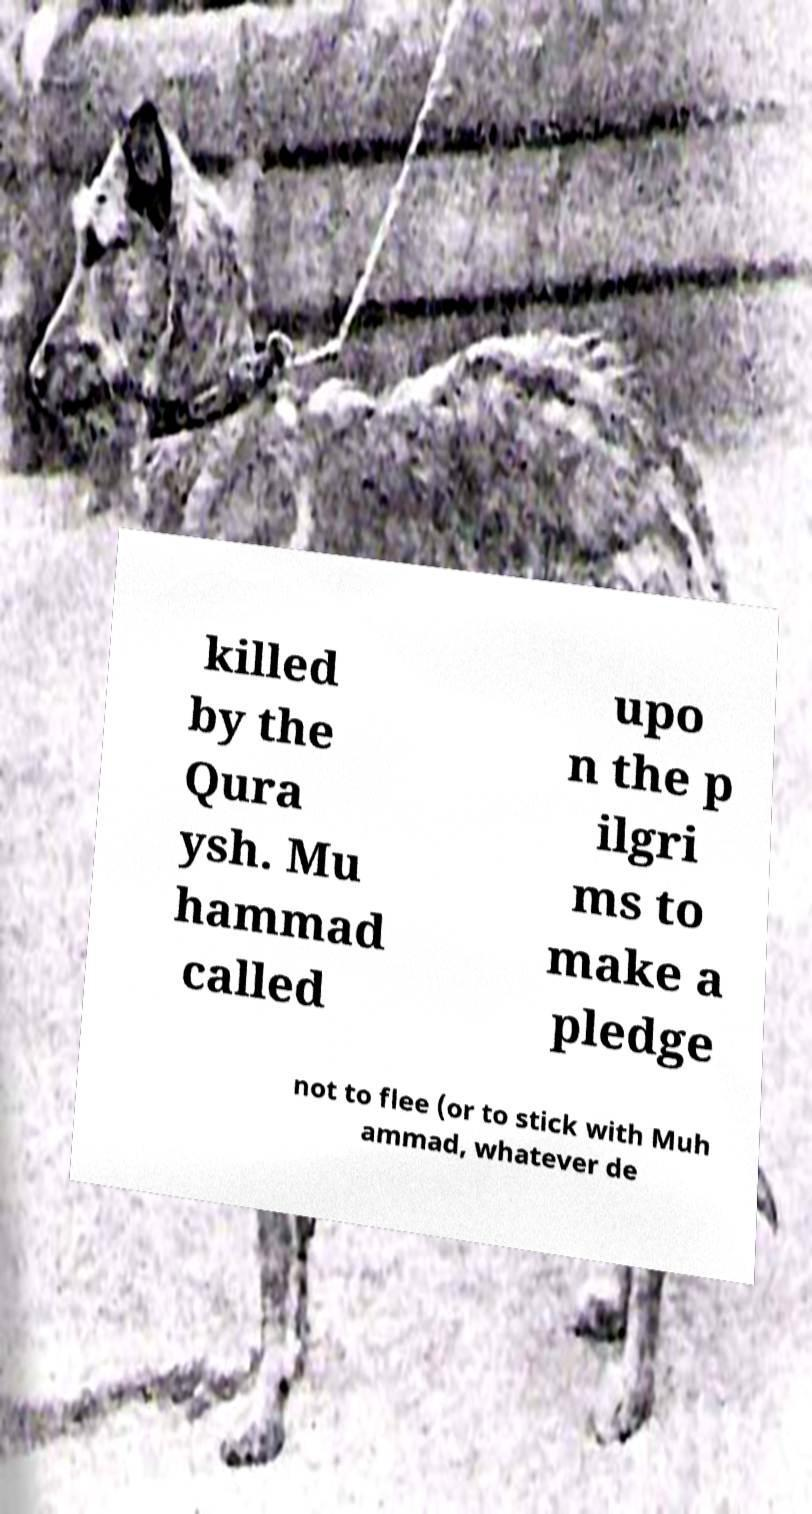Can you accurately transcribe the text from the provided image for me? killed by the Qura ysh. Mu hammad called upo n the p ilgri ms to make a pledge not to flee (or to stick with Muh ammad, whatever de 